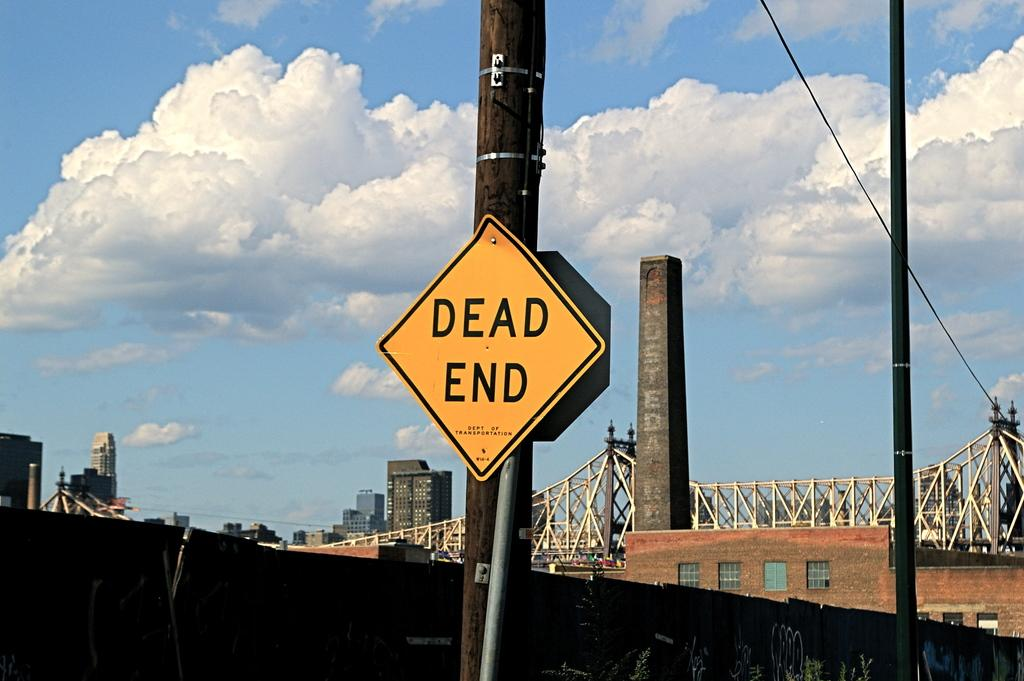Provide a one-sentence caption for the provided image. Yellow and black Dead End sign on a brown pole. 